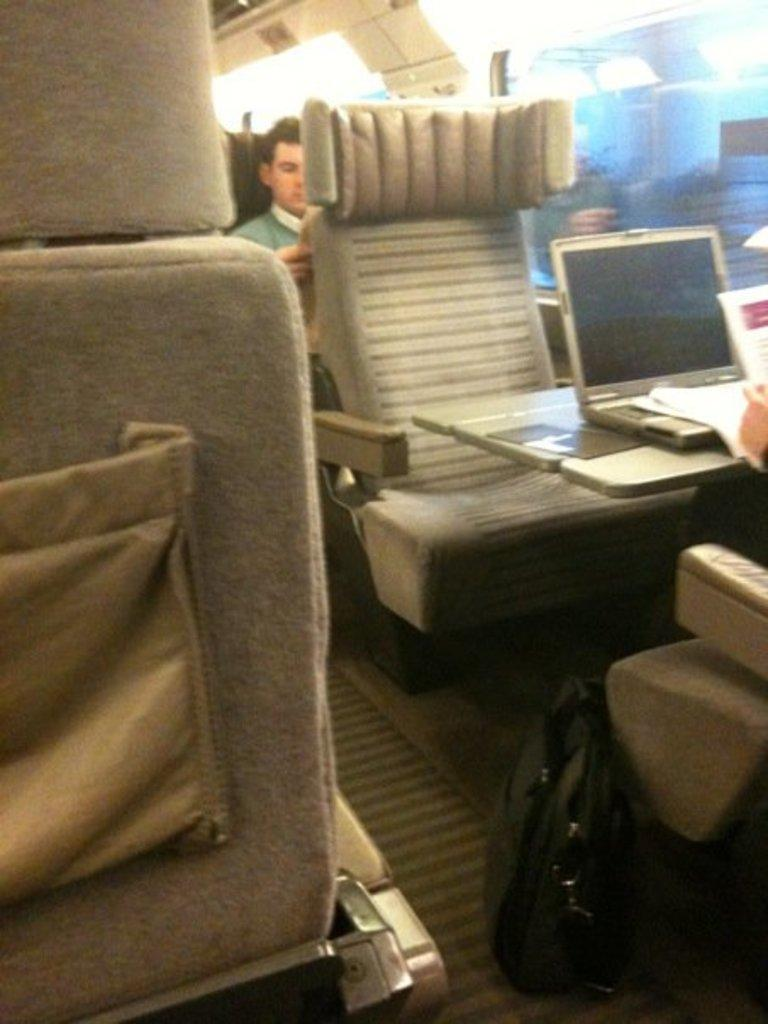What is the man in the image doing? The man is sitting on a chair in the image. What can be seen in the background of the image? There are windows visible in the image. What object is present in the image that might be used for carrying items? There is a bag in the image. What electronic device is visible in the image? There is a laptop in the image. What type of written material can be seen in the image? There are papers in the image. Where is the bomb located in the image? There is no bomb present in the image. What type of duck can be seen swimming in the bag in the image? There is no duck present in the image, let alone a duck swimming in a bag. 